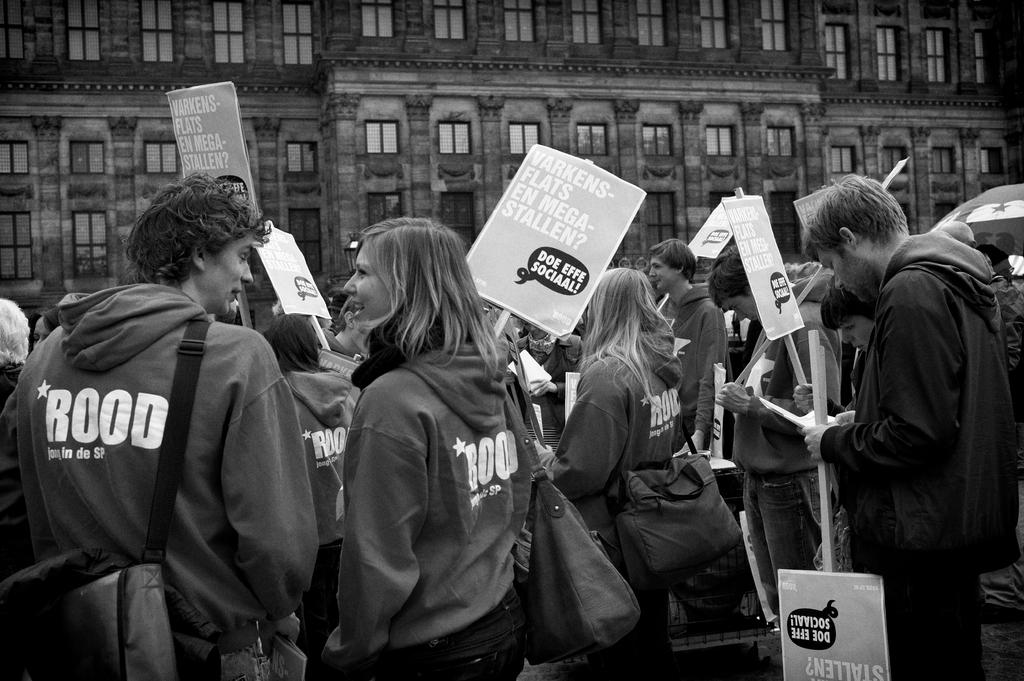What is the color scheme of the image? The image is black and white. What are the people in the image doing? People are protesting in the image. What are the protesters holding in their hands? The protesters are holding placards. What type of clothing are the protesters wearing? The protesters are wearing hoodies. What can be seen in the background of the image? There is a building in the background of the image. How many windows are visible on the building? The building has many windows. Can you tell me how far away the tiger is from the protesters in the image? There is no tiger present in the image, so it is not possible to determine its distance from the protesters. 